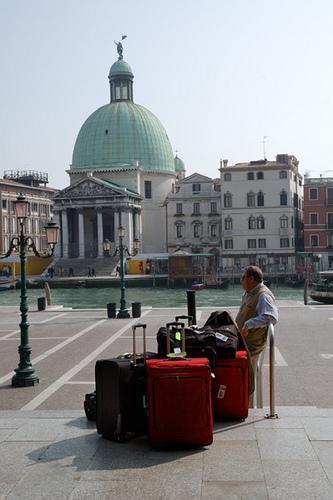What mode of transport did this person recently take advantage of?
Select the accurate answer and provide explanation: 'Answer: answer
Rationale: rationale.'
Options: Lyft, biike, uber, air travel. Answer: air travel.
Rationale: A person is standing on the curb with suitcases. people take suitcases on planes. What is this man enjoying here?
Select the accurate response from the four choices given to answer the question.
Options: Sales job, beach, sleeping, vacation. Vacation. 